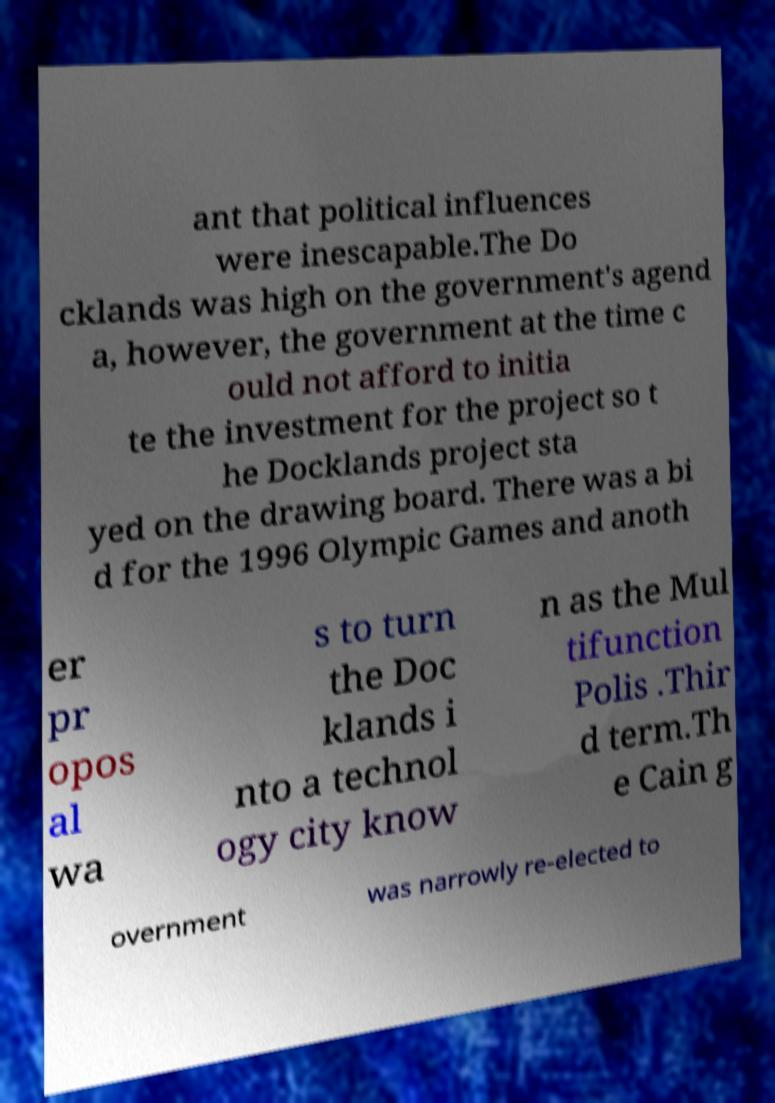Please identify and transcribe the text found in this image. ant that political influences were inescapable.The Do cklands was high on the government's agend a, however, the government at the time c ould not afford to initia te the investment for the project so t he Docklands project sta yed on the drawing board. There was a bi d for the 1996 Olympic Games and anoth er pr opos al wa s to turn the Doc klands i nto a technol ogy city know n as the Mul tifunction Polis .Thir d term.Th e Cain g overnment was narrowly re-elected to 